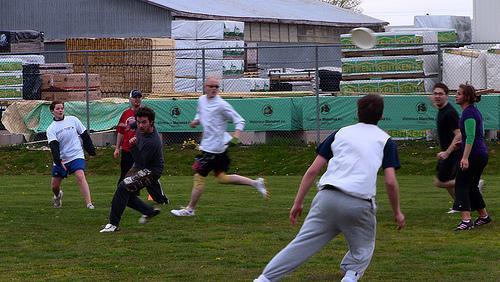How many people are seen?
Give a very brief answer. 7. How many women are there among the players?
Give a very brief answer. 1. 